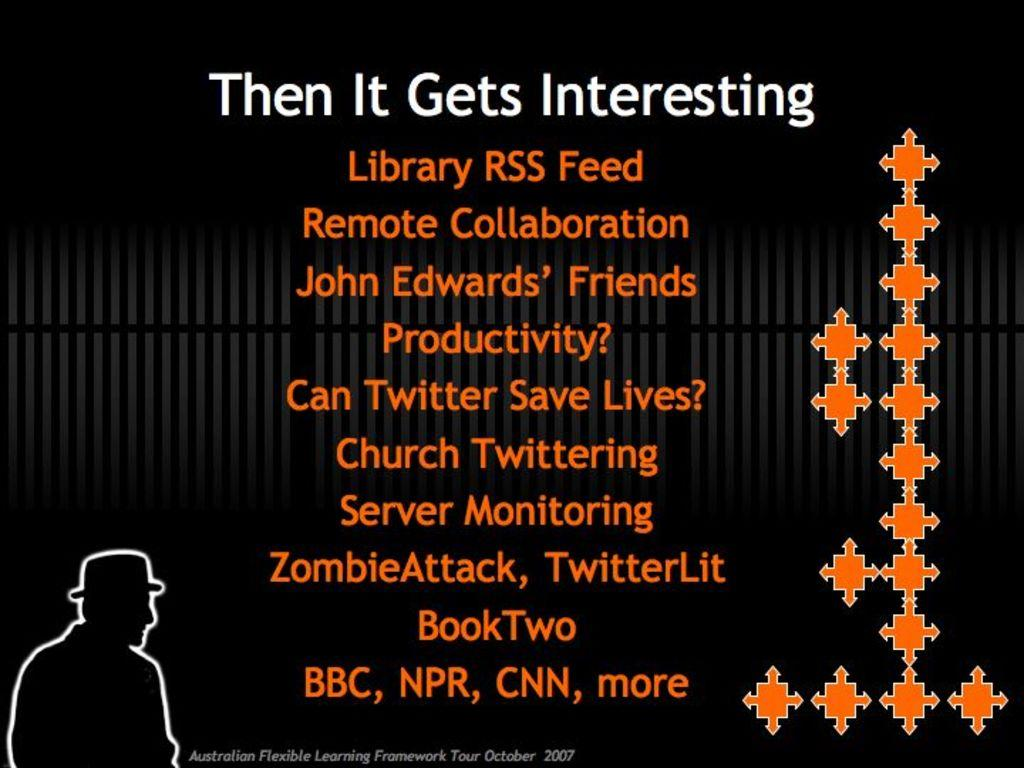What is present in the image related to a visual display? There is a poster in the image. What can be found on the poster? The poster contains text. What color is the background of the poster? The background of the poster is black. Is there a goat visible in the image? No, there is no goat present in the image. What type of voyage is depicted on the poster? The poster does not depict any voyage; it only contains text on a black background. 